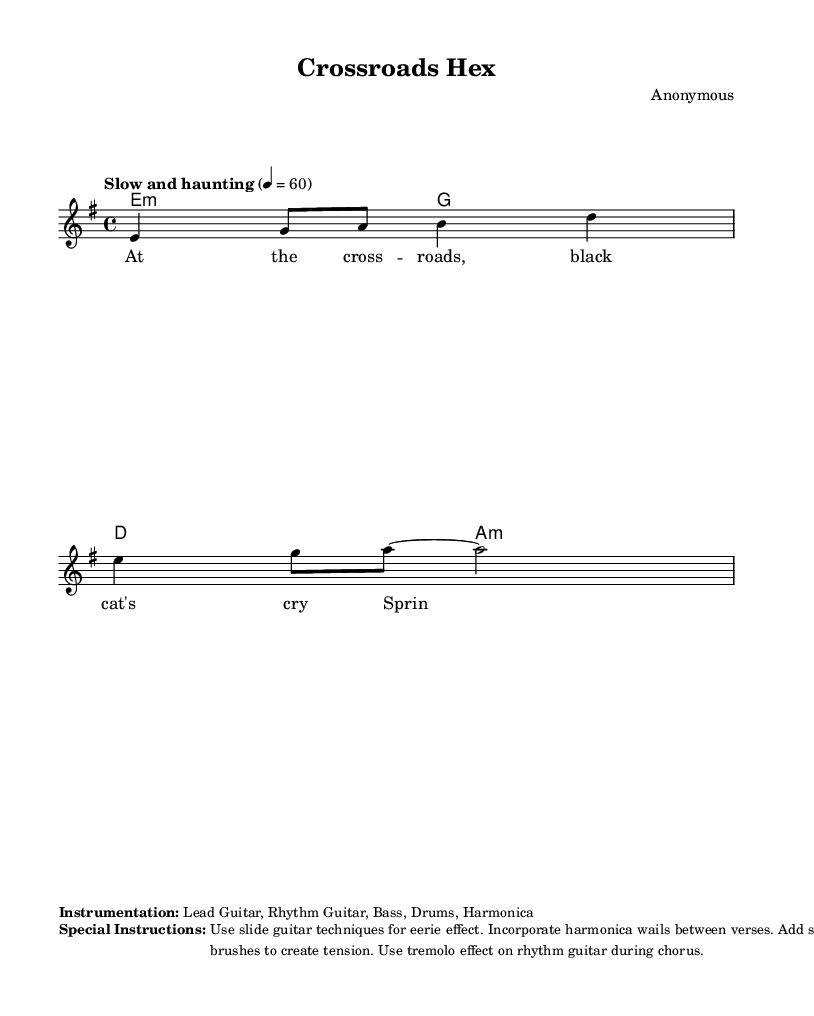What is the key signature of this music? The key signature is E minor, as indicated by the presence of one sharp (F#) on the staff.
Answer: E minor What is the time signature of this music? The time signature is 4/4, shown at the beginning of the score, indicating four beats per measure.
Answer: 4/4 What is the tempo marking of this piece? The tempo marking "Slow and haunting" defines the mood and pace of the piece and advises performers to play it slowly.
Answer: Slow and haunting What instruments are specified for this music? The sheet music specifies Lead Guitar, Rhythm Guitar, Bass, Drums, and Harmonica as the instrumentation.
Answer: Lead Guitar, Rhythm Guitar, Bass, Drums, Harmonica How many measures are in the provided section of music? Counting the measures presented in the melody and harmonies, there are a total of two measures in this excerpt.
Answer: 2 Why is the black cat mentioned in the lyrics? The mention of a black cat is a traditional superstition associated with bad luck or witchcraft in the Deep South, reflecting the blues' connection to folklore and spiritual beliefs.
Answer: Bad luck What technique is suggested for the lead guitar? The score instructs to use slide guitar techniques to achieve an eerie effect, which is a common stylistic element in blues music.
Answer: Slide guitar techniques 